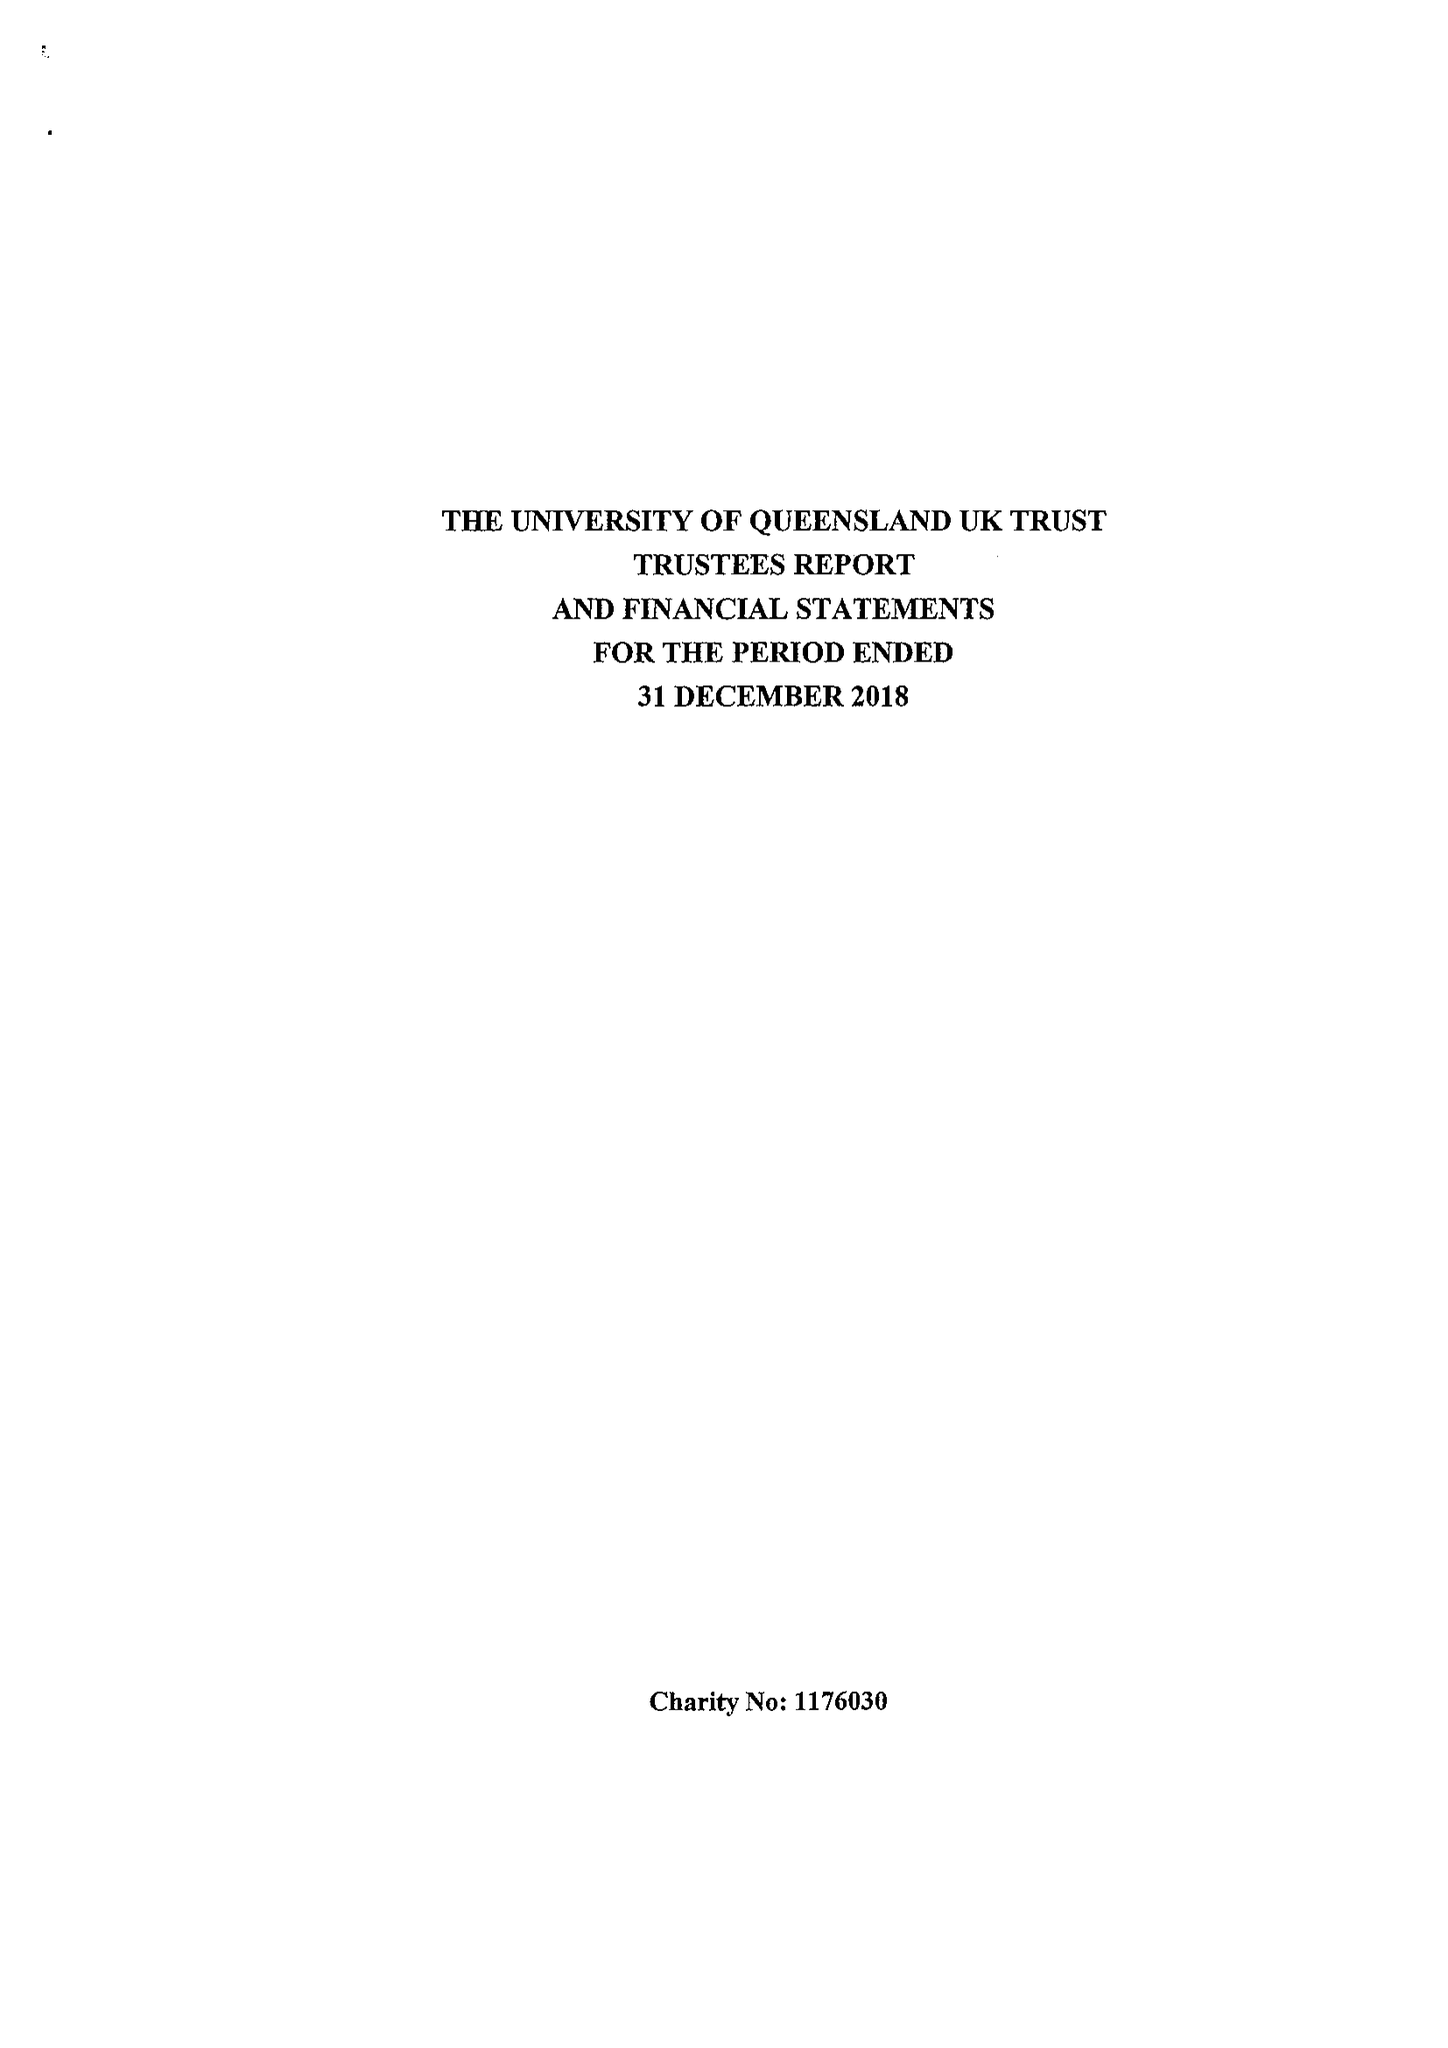What is the value for the address__post_town?
Answer the question using a single word or phrase. LINGFIELD 